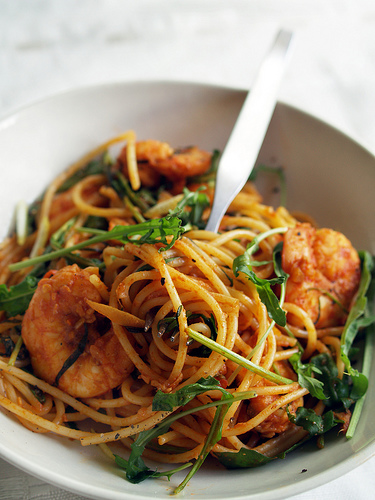<image>
Is the food in the bowl? Yes. The food is contained within or inside the bowl, showing a containment relationship. Is there a noodles behind the bowl? No. The noodles is not behind the bowl. From this viewpoint, the noodles appears to be positioned elsewhere in the scene. 